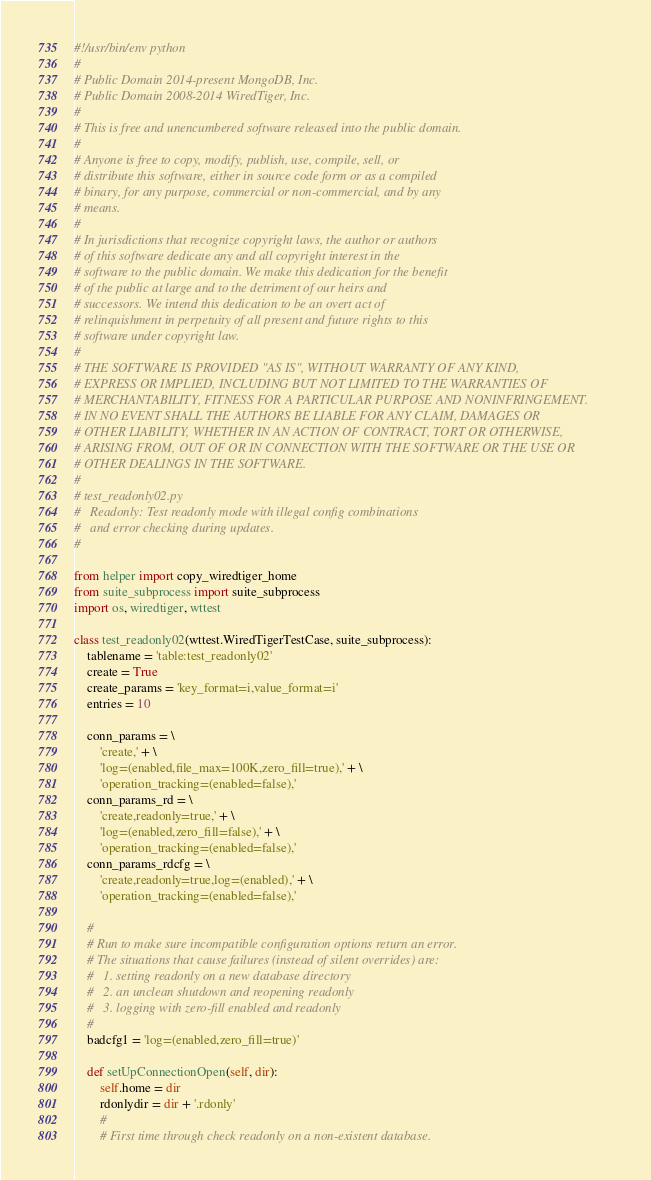<code> <loc_0><loc_0><loc_500><loc_500><_Python_>#!/usr/bin/env python
#
# Public Domain 2014-present MongoDB, Inc.
# Public Domain 2008-2014 WiredTiger, Inc.
#
# This is free and unencumbered software released into the public domain.
#
# Anyone is free to copy, modify, publish, use, compile, sell, or
# distribute this software, either in source code form or as a compiled
# binary, for any purpose, commercial or non-commercial, and by any
# means.
#
# In jurisdictions that recognize copyright laws, the author or authors
# of this software dedicate any and all copyright interest in the
# software to the public domain. We make this dedication for the benefit
# of the public at large and to the detriment of our heirs and
# successors. We intend this dedication to be an overt act of
# relinquishment in perpetuity of all present and future rights to this
# software under copyright law.
#
# THE SOFTWARE IS PROVIDED "AS IS", WITHOUT WARRANTY OF ANY KIND,
# EXPRESS OR IMPLIED, INCLUDING BUT NOT LIMITED TO THE WARRANTIES OF
# MERCHANTABILITY, FITNESS FOR A PARTICULAR PURPOSE AND NONINFRINGEMENT.
# IN NO EVENT SHALL THE AUTHORS BE LIABLE FOR ANY CLAIM, DAMAGES OR
# OTHER LIABILITY, WHETHER IN AN ACTION OF CONTRACT, TORT OR OTHERWISE,
# ARISING FROM, OUT OF OR IN CONNECTION WITH THE SOFTWARE OR THE USE OR
# OTHER DEALINGS IN THE SOFTWARE.
#
# test_readonly02.py
#   Readonly: Test readonly mode with illegal config combinations
#   and error checking during updates.
#

from helper import copy_wiredtiger_home
from suite_subprocess import suite_subprocess
import os, wiredtiger, wttest

class test_readonly02(wttest.WiredTigerTestCase, suite_subprocess):
    tablename = 'table:test_readonly02'
    create = True
    create_params = 'key_format=i,value_format=i'
    entries = 10

    conn_params = \
        'create,' + \
        'log=(enabled,file_max=100K,zero_fill=true),' + \
        'operation_tracking=(enabled=false),'
    conn_params_rd = \
        'create,readonly=true,' + \
        'log=(enabled,zero_fill=false),' + \
        'operation_tracking=(enabled=false),'
    conn_params_rdcfg = \
        'create,readonly=true,log=(enabled),' + \
        'operation_tracking=(enabled=false),'

    #
    # Run to make sure incompatible configuration options return an error.
    # The situations that cause failures (instead of silent overrides) are:
    #   1. setting readonly on a new database directory
    #   2. an unclean shutdown and reopening readonly
    #   3. logging with zero-fill enabled and readonly
    #
    badcfg1 = 'log=(enabled,zero_fill=true)'

    def setUpConnectionOpen(self, dir):
        self.home = dir
        rdonlydir = dir + '.rdonly'
        #
        # First time through check readonly on a non-existent database.</code> 